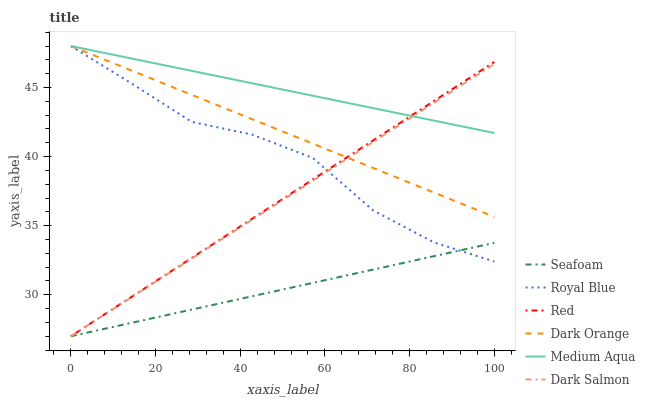Does Seafoam have the minimum area under the curve?
Answer yes or no. Yes. Does Medium Aqua have the maximum area under the curve?
Answer yes or no. Yes. Does Dark Salmon have the minimum area under the curve?
Answer yes or no. No. Does Dark Salmon have the maximum area under the curve?
Answer yes or no. No. Is Seafoam the smoothest?
Answer yes or no. Yes. Is Royal Blue the roughest?
Answer yes or no. Yes. Is Dark Salmon the smoothest?
Answer yes or no. No. Is Dark Salmon the roughest?
Answer yes or no. No. Does Dark Salmon have the lowest value?
Answer yes or no. Yes. Does Royal Blue have the lowest value?
Answer yes or no. No. Does Medium Aqua have the highest value?
Answer yes or no. Yes. Does Dark Salmon have the highest value?
Answer yes or no. No. Is Seafoam less than Dark Orange?
Answer yes or no. Yes. Is Medium Aqua greater than Seafoam?
Answer yes or no. Yes. Does Royal Blue intersect Red?
Answer yes or no. Yes. Is Royal Blue less than Red?
Answer yes or no. No. Is Royal Blue greater than Red?
Answer yes or no. No. Does Seafoam intersect Dark Orange?
Answer yes or no. No. 